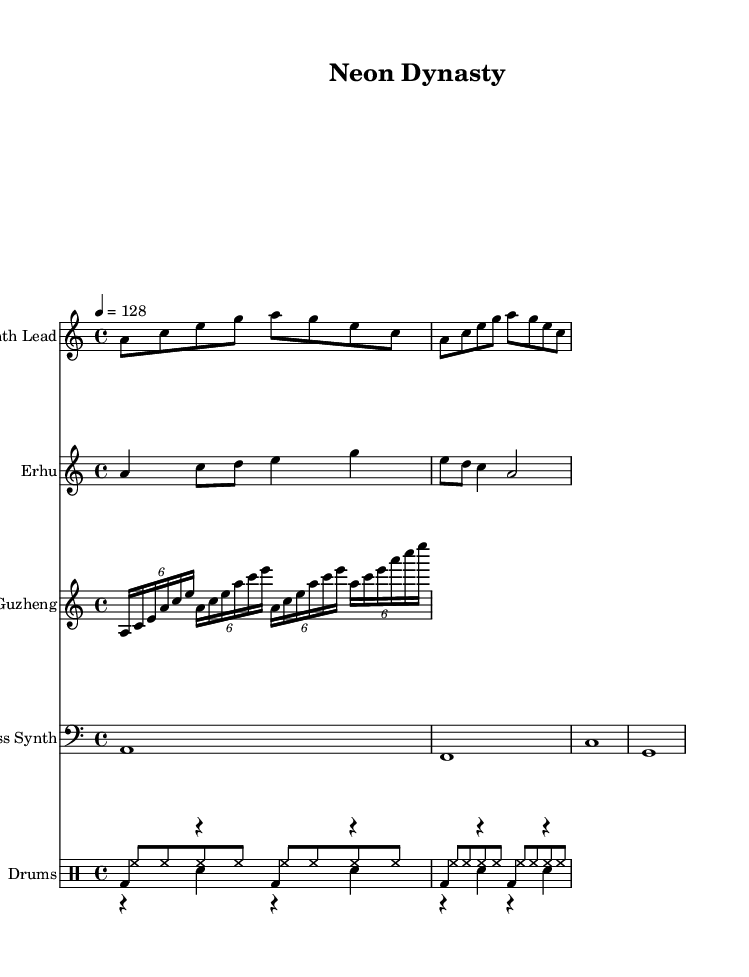What is the key signature of this music? The key signature is A minor, indicated by the presence of no sharps or flats. The music also follows the relative major of C major.
Answer: A minor What is the time signature of this piece? The time signature shown is 4/4, meaning there are four beats in each measure and the quarter note gets one beat. This is a common time signature for dance music.
Answer: 4/4 What is the tempo of the piece? The indicated tempo is 128 beats per minute, which is a typical tempo for high-energy electronic dance music to maintain a lively rhythm.
Answer: 128 How many measures does the synth lead section contain? The synth lead section consists of two measures, as indicated by the grouping of notes without any double bar lines or rest sections in between.
Answer: 2 What instruments are featured in the composition? The composition features a Synth Lead, Erhu, Guzheng, Bass Synth, and Drums. The instruments are listed above their respective staves on the sheet music.
Answer: Synth Lead, Erhu, Guzheng, Bass Synth, Drums Which traditional Chinese instrument plays the melody? The melody is played by the Erhu, which is indicated in the respective staff labeled as "Erhu." This instrument is known for its expressive capability and is a staple in traditional Chinese music.
Answer: Erhu What type of dance music does this piece represent? This piece represents electronic dance music with fusion elements from traditional Chinese instruments, blending modern and traditional styles to create a high-energy track suitable for dancing.
Answer: Dance 